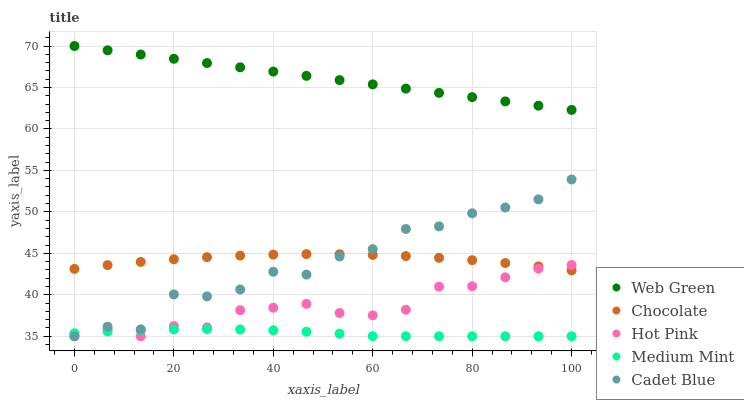Does Medium Mint have the minimum area under the curve?
Answer yes or no. Yes. Does Web Green have the maximum area under the curve?
Answer yes or no. Yes. Does Hot Pink have the minimum area under the curve?
Answer yes or no. No. Does Hot Pink have the maximum area under the curve?
Answer yes or no. No. Is Web Green the smoothest?
Answer yes or no. Yes. Is Cadet Blue the roughest?
Answer yes or no. Yes. Is Hot Pink the smoothest?
Answer yes or no. No. Is Hot Pink the roughest?
Answer yes or no. No. Does Medium Mint have the lowest value?
Answer yes or no. Yes. Does Web Green have the lowest value?
Answer yes or no. No. Does Web Green have the highest value?
Answer yes or no. Yes. Does Hot Pink have the highest value?
Answer yes or no. No. Is Medium Mint less than Web Green?
Answer yes or no. Yes. Is Web Green greater than Medium Mint?
Answer yes or no. Yes. Does Medium Mint intersect Cadet Blue?
Answer yes or no. Yes. Is Medium Mint less than Cadet Blue?
Answer yes or no. No. Is Medium Mint greater than Cadet Blue?
Answer yes or no. No. Does Medium Mint intersect Web Green?
Answer yes or no. No. 